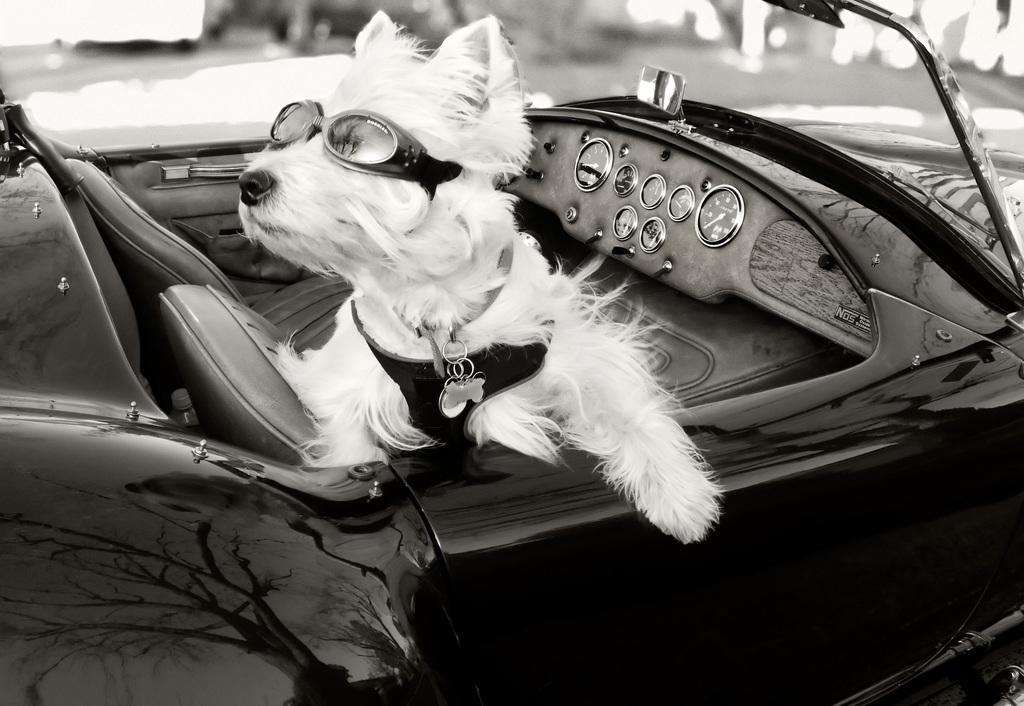In one or two sentences, can you explain what this image depicts? In this image i can see a dog sitting in a car. 